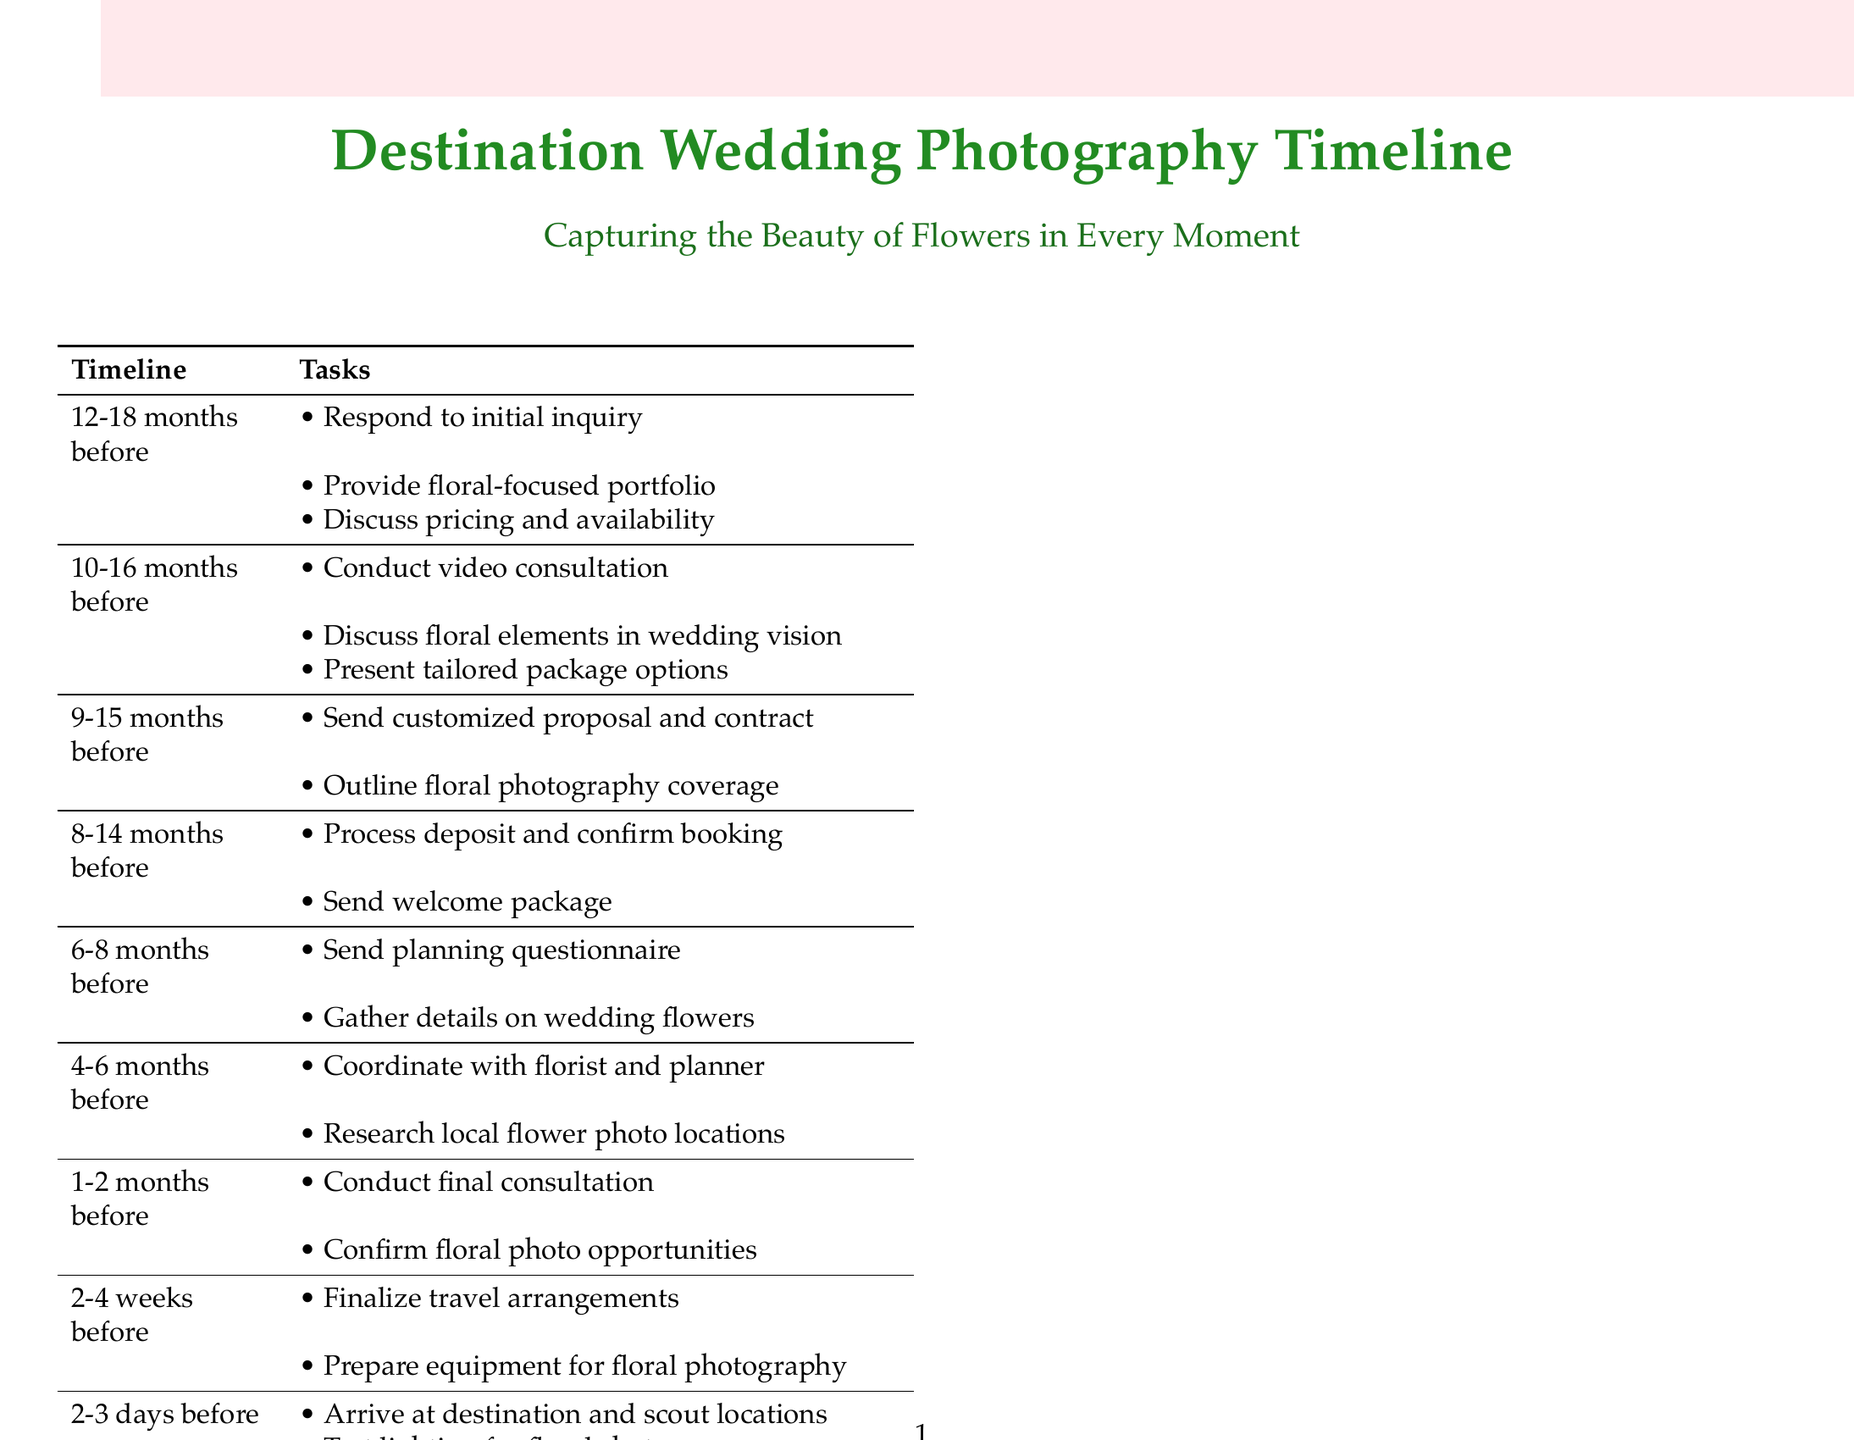what is the timeline for initial inquiry? The initial inquiry is scheduled for 12-18 months before the wedding.
Answer: 12-18 months before what is the main focus of the consultation call? The main focus of the consultation call is discussing the wedding vision, especially floral elements.
Answer: Floral elements how long before the wedding should the proposal and contract be sent? The proposal and contract should be sent 9-15 months before the wedding.
Answer: 9-15 months before what should be reviewed during the final consultation? During the final consultation, the final wedding day timeline and specific floral photo opportunities should be reviewed.
Answer: Final timeline and floral photo opportunities when should travel arrangements be finalized? Travel arrangements should be finalized 2-4 weeks before the wedding.
Answer: 2-4 weeks before how many days before the wedding does location scouting occur? Location scouting occurs 2-3 days before the wedding.
Answer: 2-3 days before what type of shots are emphasized on the wedding day? The wedding day emphasizes capturing floral details and creating artistic shots with local flora.
Answer: Floral details and local flora what is included in the welcome package after booking confirmation? The welcome package includes information to help the couple prepare for their destination wedding photography.
Answer: Information for preparation how many months before the wedding should the planning questionnaire be sent? The planning questionnaire should be sent 6-8 months before the wedding.
Answer: 6-8 months before 